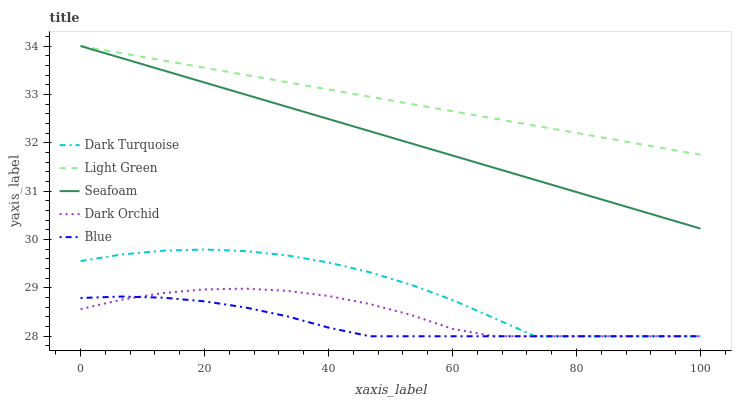Does Blue have the minimum area under the curve?
Answer yes or no. Yes. Does Light Green have the maximum area under the curve?
Answer yes or no. Yes. Does Dark Turquoise have the minimum area under the curve?
Answer yes or no. No. Does Dark Turquoise have the maximum area under the curve?
Answer yes or no. No. Is Seafoam the smoothest?
Answer yes or no. Yes. Is Dark Turquoise the roughest?
Answer yes or no. Yes. Is Dark Turquoise the smoothest?
Answer yes or no. No. Is Seafoam the roughest?
Answer yes or no. No. Does Dark Orchid have the lowest value?
Answer yes or no. Yes. Does Seafoam have the lowest value?
Answer yes or no. No. Does Light Green have the highest value?
Answer yes or no. Yes. Does Dark Turquoise have the highest value?
Answer yes or no. No. Is Dark Orchid less than Seafoam?
Answer yes or no. Yes. Is Seafoam greater than Dark Orchid?
Answer yes or no. Yes. Does Dark Turquoise intersect Dark Orchid?
Answer yes or no. Yes. Is Dark Turquoise less than Dark Orchid?
Answer yes or no. No. Is Dark Turquoise greater than Dark Orchid?
Answer yes or no. No. Does Dark Orchid intersect Seafoam?
Answer yes or no. No. 